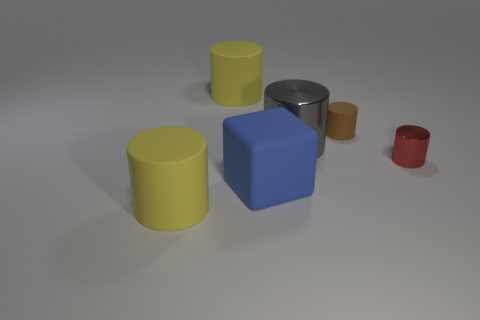Is the shape of the red object the same as the tiny rubber object? While the red and tiny rubber objects in the image are both cylindrical in shape, providing a comprehensive answer requires a closer examination to compare their exact dimensions and any subtle differences that may not be immediately apparent from this perspective. 